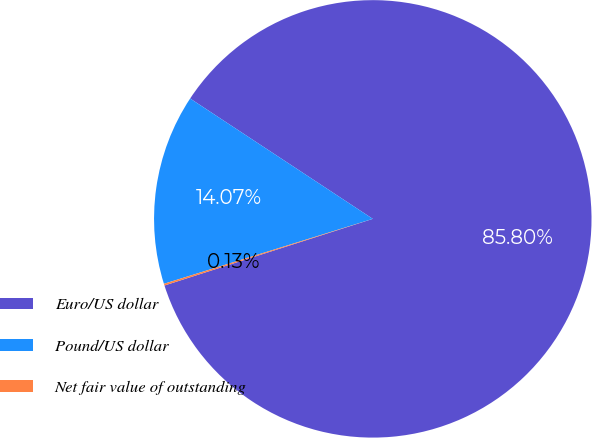<chart> <loc_0><loc_0><loc_500><loc_500><pie_chart><fcel>Euro/US dollar<fcel>Pound/US dollar<fcel>Net fair value of outstanding<nl><fcel>85.8%<fcel>14.07%<fcel>0.13%<nl></chart> 